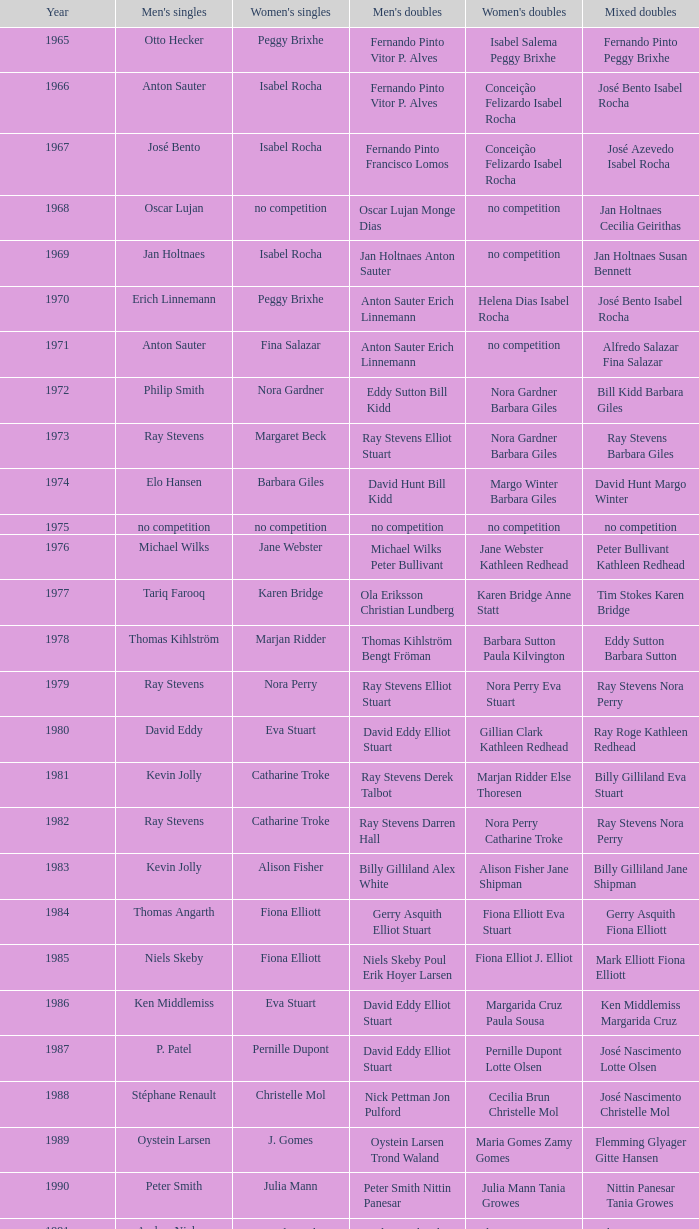After 1987, which women's doubles occurred subsequent to a women's single featuring astrid van der knaap? Elena Denisova Marina Yakusheva. 